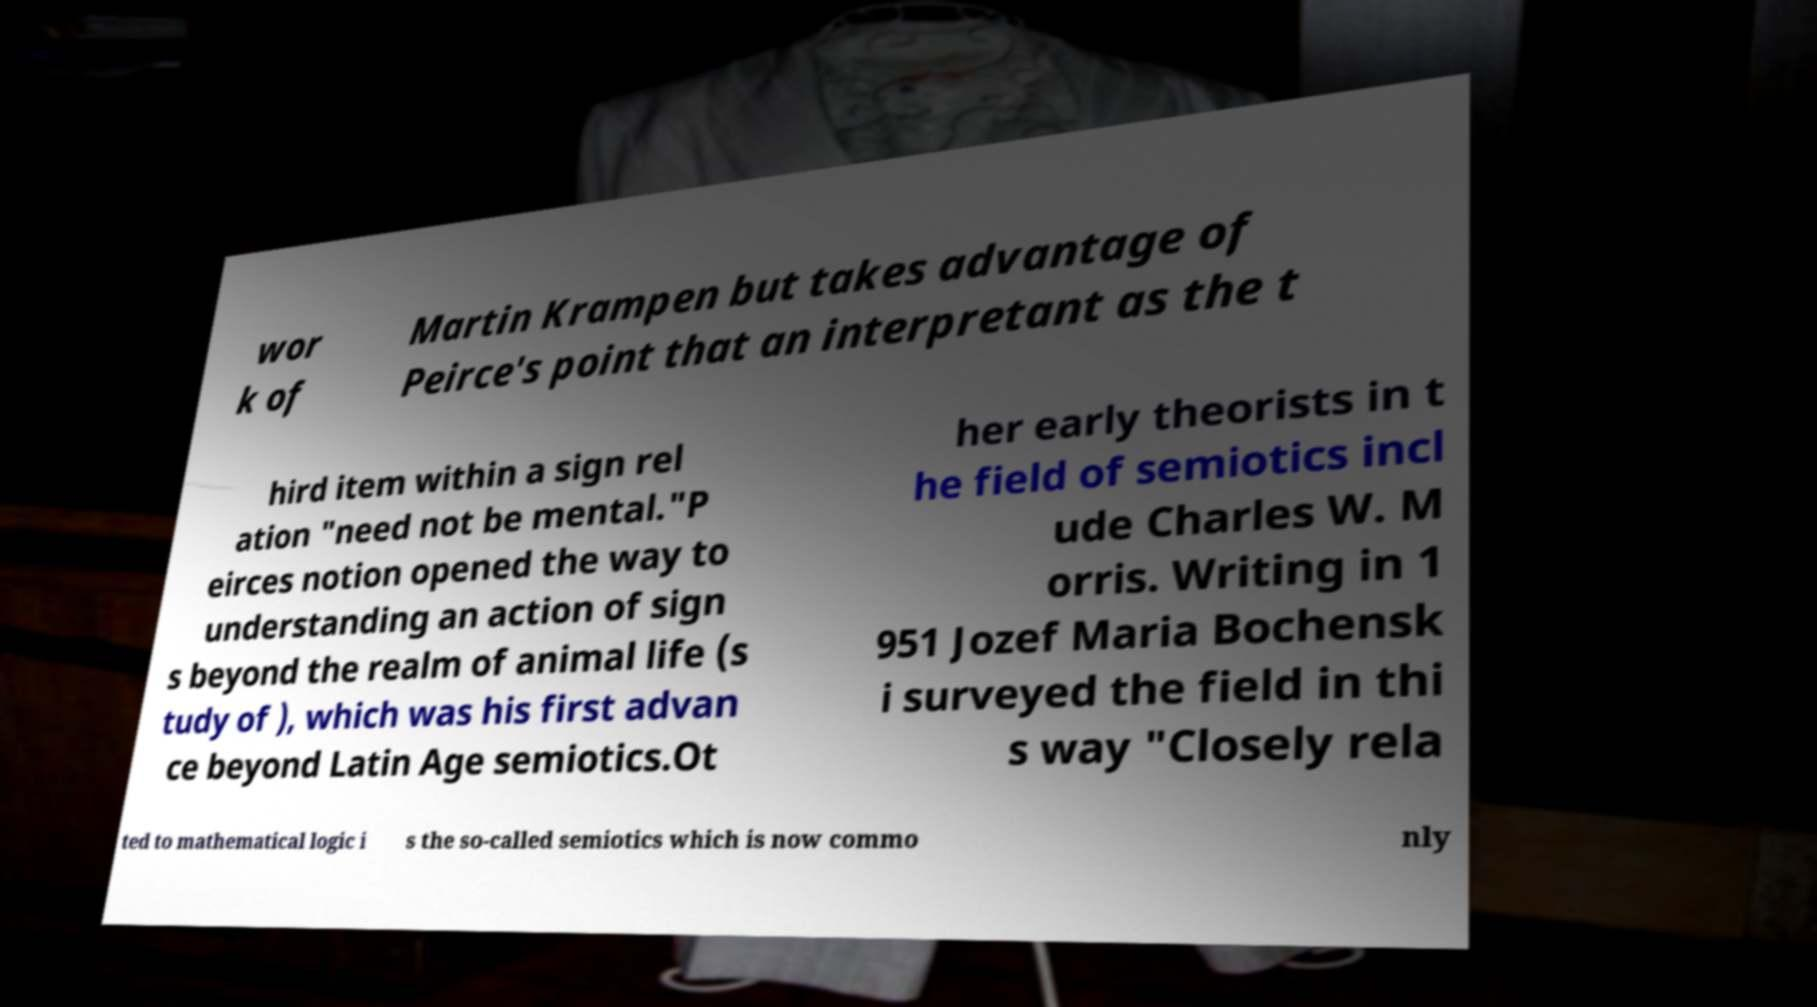There's text embedded in this image that I need extracted. Can you transcribe it verbatim? wor k of Martin Krampen but takes advantage of Peirce's point that an interpretant as the t hird item within a sign rel ation "need not be mental."P eirces notion opened the way to understanding an action of sign s beyond the realm of animal life (s tudy of ), which was his first advan ce beyond Latin Age semiotics.Ot her early theorists in t he field of semiotics incl ude Charles W. M orris. Writing in 1 951 Jozef Maria Bochensk i surveyed the field in thi s way "Closely rela ted to mathematical logic i s the so-called semiotics which is now commo nly 